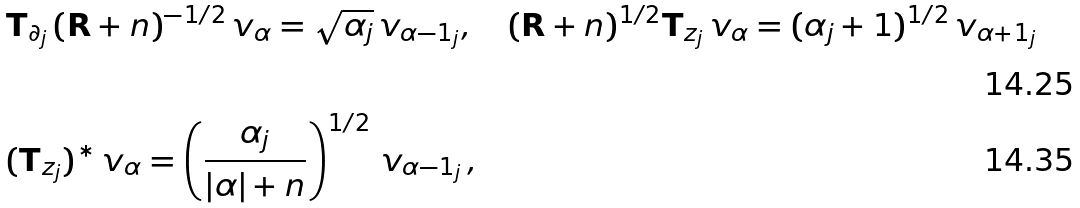<formula> <loc_0><loc_0><loc_500><loc_500>& \mathbf T _ { \partial _ { j } } \, ( \mathbf R + n ) ^ { - 1 / 2 } \, v _ { \alpha } = \sqrt { \alpha _ { j } } \, v _ { \alpha - 1 _ { j } } , \quad ( \mathbf R + n ) ^ { 1 / 2 } \mathbf T _ { z _ { j } } \, v _ { \alpha } = ( \alpha _ { j } + 1 ) ^ { 1 / 2 } \, v _ { \alpha + 1 _ { j } } \\ & ( \mathbf T _ { z _ { j } } ) ^ { * } \, v _ { \alpha } = \left ( \frac { \alpha _ { j } } { | \alpha | + n } \right ) ^ { 1 / 2 } \, v _ { \alpha - 1 _ { j } } \, ,</formula> 